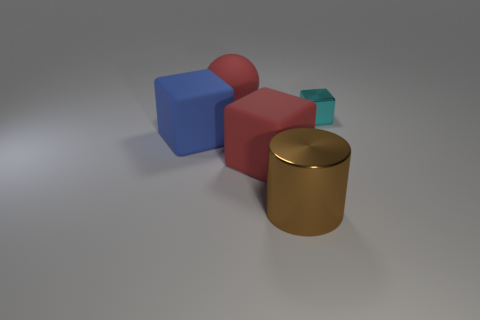Subtract all matte cubes. How many cubes are left? 1 Add 4 metal objects. How many objects exist? 9 Subtract 2 blocks. How many blocks are left? 1 Subtract all spheres. How many objects are left? 4 Subtract all cyan cubes. How many cubes are left? 2 Subtract all purple spheres. Subtract all purple cubes. How many spheres are left? 1 Subtract all big blocks. Subtract all red blocks. How many objects are left? 2 Add 1 objects. How many objects are left? 6 Add 1 large blue cubes. How many large blue cubes exist? 2 Subtract 0 cyan spheres. How many objects are left? 5 